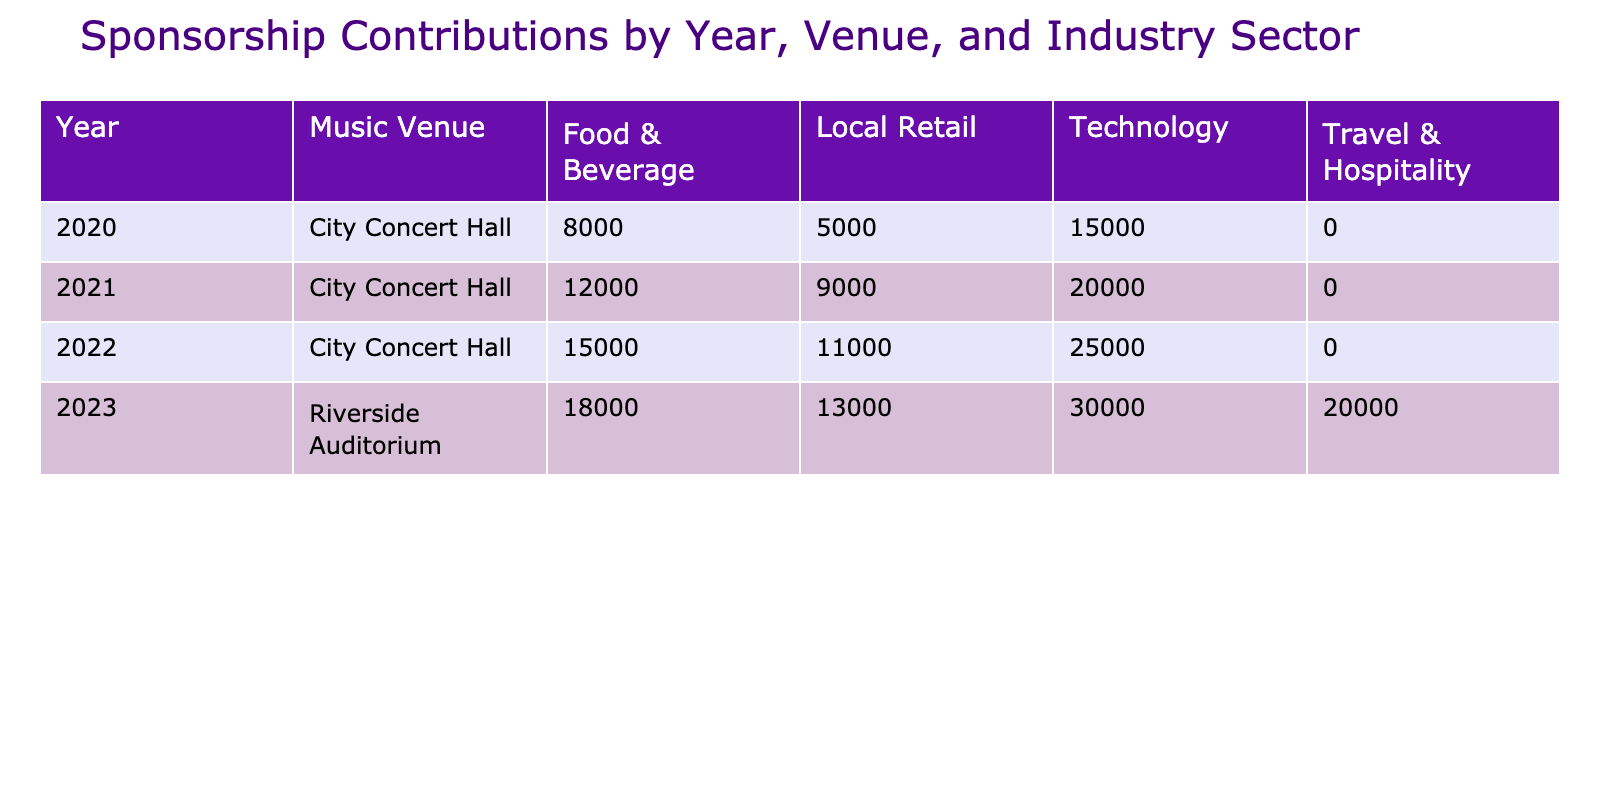What was the total sponsorship contribution from the Food & Beverage sector in 2022? The table shows the contributions for the Food & Beverage sector in 2022. The contribution was 15,000 USD.
Answer: 15,000 USD Which year saw the highest contribution from the Technology sector? The table shows contributions for the Technology sector across years. The highest contribution is 30,000 USD in 2023.
Answer: 30,000 USD Did the Local Retail sector contribute more in 2023 than in 2022? In 2023, the Local Retail sector contributed 13,000 USD, while in 2022, it contributed 11,000 USD. Therefore, it did contribute more in 2023.
Answer: Yes What was the average sponsorship contribution from the Technology sector across all years? The contributions from the Technology sector are 15,000 (2020), 20,000 (2021), 25,000 (2022), and 30,000 (2023). Summing them gives 90,000 USD. Since there are 4 years, the average is 90,000/4 = 22,500 USD.
Answer: 22,500 USD What was the total amount contributed by the Food & Beverage and Local Retail sectors in 2021? The Food & Beverage contribution in 2021 was 12,000 USD, and the Local Retail was 9,000 USD. Adding these two contributions gives 12,000 + 9,000 = 21,000 USD.
Answer: 21,000 USD Was there any year when the total contribution from the Travel & Hospitality sector exceeded 10,000 USD? In the table, the Travel & Hospitality sector only has a contribution listed for 2023 at 20,000 USD. This exceeds 10,000 USD.
Answer: Yes What is the total sponsorship contribution across all years and sectors? By summing all contributions in the table: 15,000 + 8,000 + 5,000 + 20,000 + 12,000 + 9,000 + 25,000 + 15,000 + 11,000 + 30,000 + 18,000 + 13,000 + 20,000 =  276,000 USD.
Answer: 276,000 USD In which venue did the Food & Beverage sector contribute the least? The Food & Beverage contributions are 8,000 USD in City Concert Hall in 2020, 12,000 USD in 2021, 15,000 USD in 2022, and 18,000 USD in Riverside Auditorium in 2023. The least is 8,000 USD.
Answer: City Concert Hall What was the difference in sponsorship contributions from the Technology sector between 2021 and 2023? The Technology contribution in 2023 is 30,000 USD and in 2021 it is 20,000 USD. The difference is 30,000 - 20,000 = 10,000 USD.
Answer: 10,000 USD 